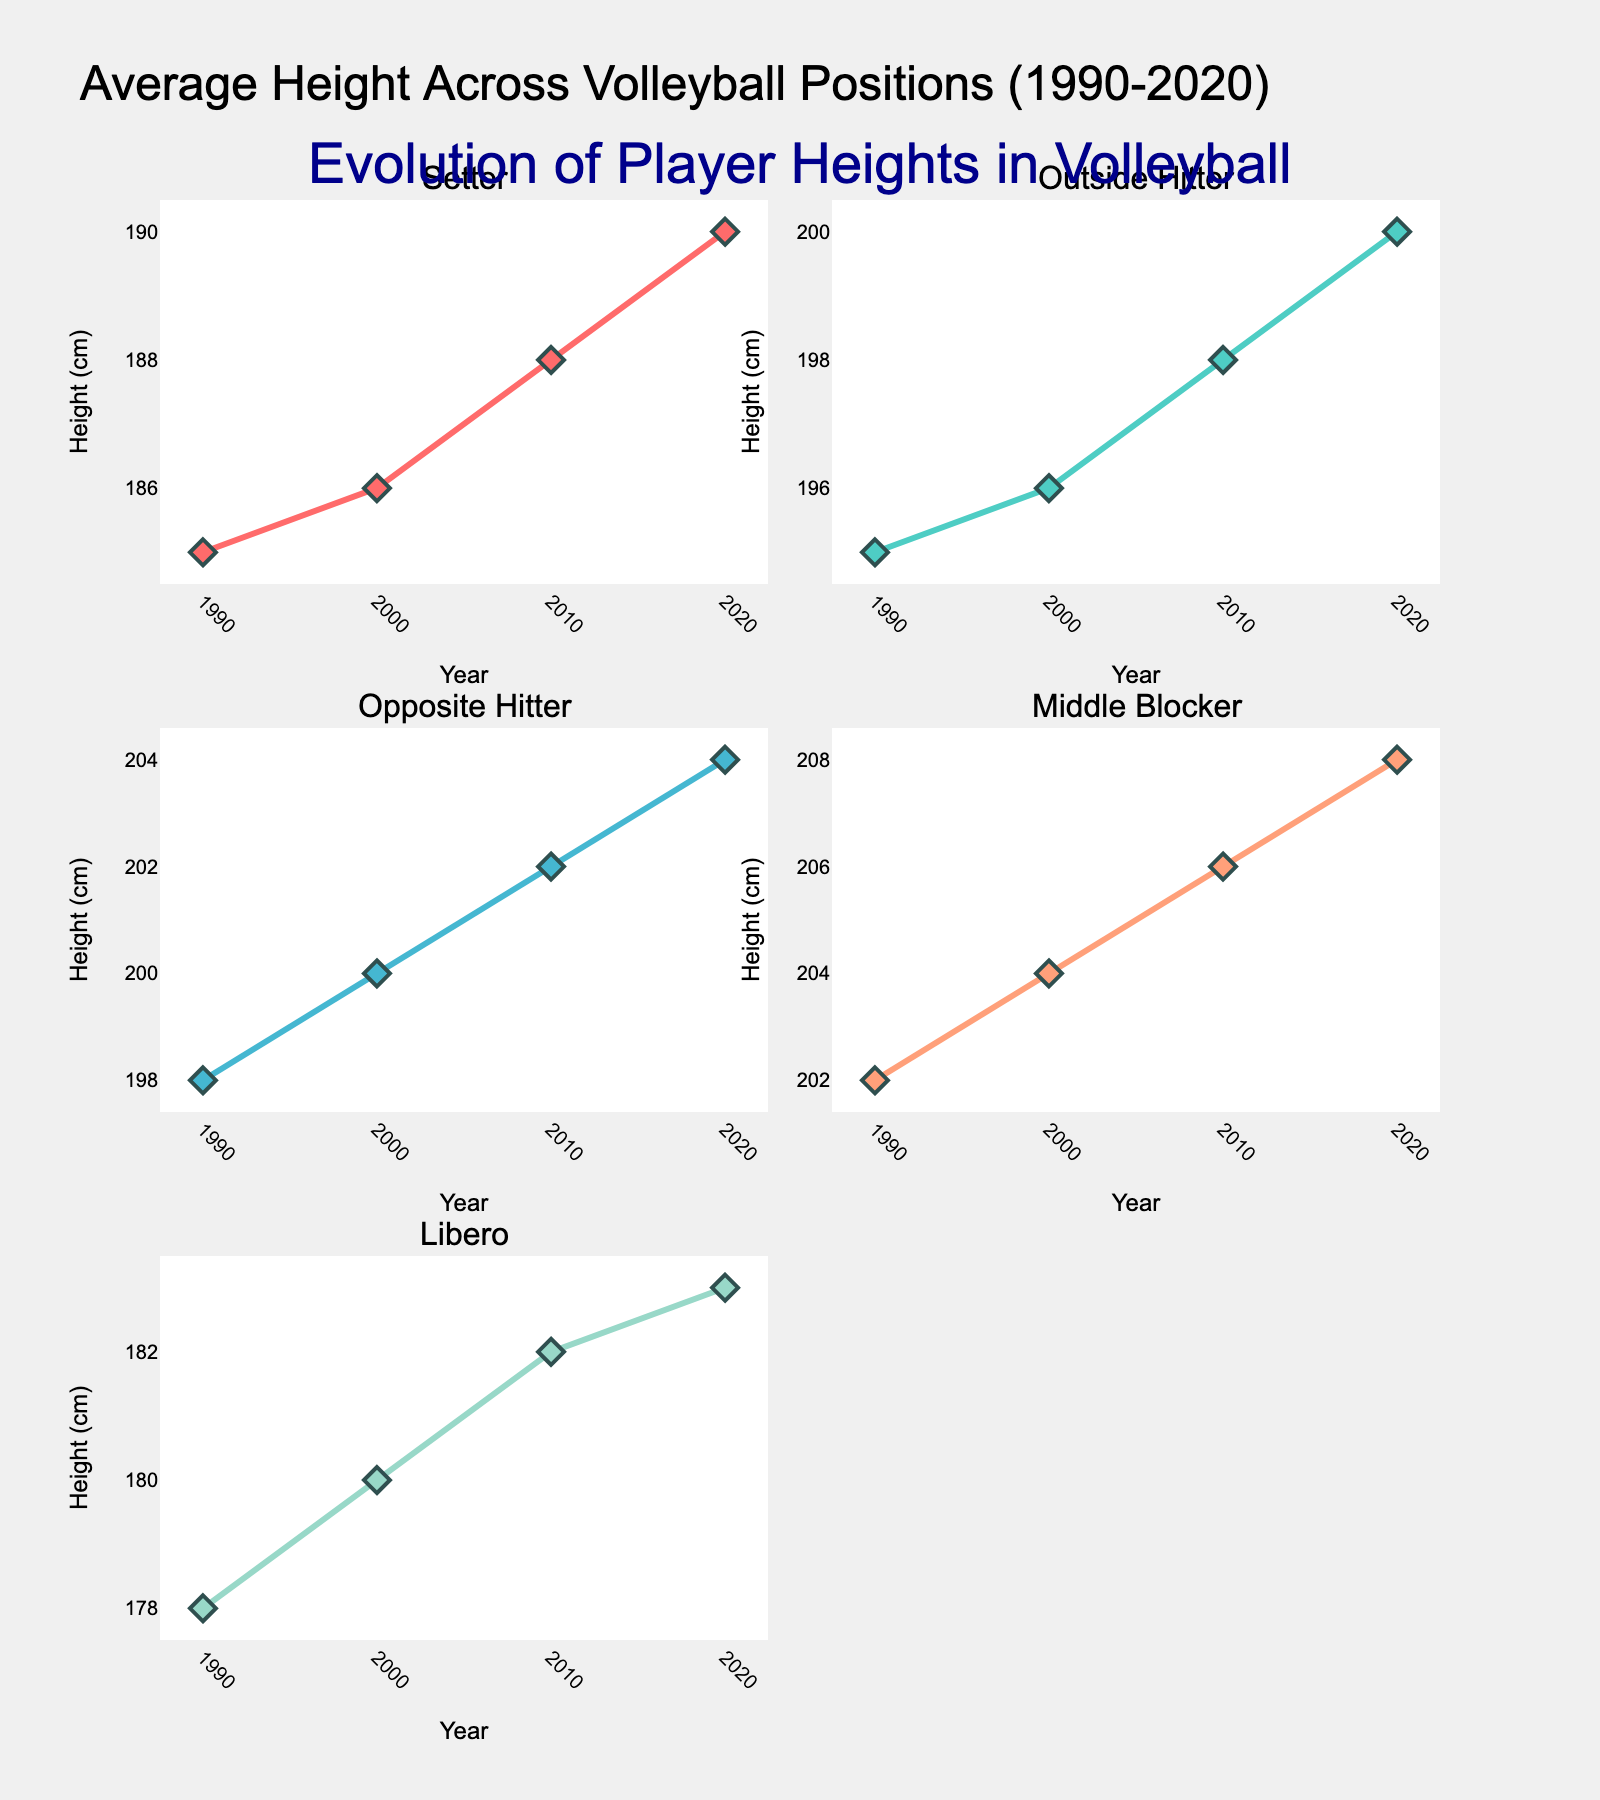What is the main title of the figure? The main title is displayed prominently at the top of the figure. By reading what is there, we can answer this question.
Answer: "Average Height Across Volleyball Positions (1990-2020)" Which volleyball position showed the most consistent increase in height over the years? Observing the slope of the lines for each position across the years, we see which line steadily increases without fluctuations. Each position line shows slight increases, but the Middle Blocker has the most linear and consistent increase.
Answer: Middle Blocker How has the average height of the Setter position changed from 1990 to 2020? By comparing the first and last data points of the Setter plot, we see the change. Starting in 1990 at 185 cm and increasing to 190 cm in 2020, the difference is observed.
Answer: Increased by 5 cm Which year had the highest average height for Outside Hitters? The subplot for Outside Hitters shows the height for each year. By finding the maximum value within the years and corresponding height, we identify the year.
Answer: 2020 What is the difference in height between Outside Hitters and Middle Blockers in 2000? Looking at the figure for both positions in the year 2000, Outside Hitters are at 196 cm, and Middle Blockers are at 204 cm. Subtracting these values gives the height difference.
Answer: 8 cm How many subplots does the figure contain? By counting the individual plots arranged for each volleyball position, we can sum up the total number. There are separate plots for Setter, Outside Hitter, Opposite Hitter, Middle Blocker, and Libero, laid out in the subplot grid.
Answer: 5 Between which years did the Libero position see the biggest change in average height? Looking at the diagram for the Libero position, the heights are listed for each decade. By calculating the differences between each decade and comparing them, we identify the largest change. From 1990 (178 cm) to 2000 (180 cm), the change is 2 cm, from 2000 to 2010 (182 cm) is 2 cm, and from 2010 to 2020 (183 cm) is 1 cm. The largest change is equal between 2000 and 2010.
Answer: 2000 to 2010 Which position had the smallest average height increase from 1990 to 2020? Checking the height changes for each position over time, the Setter’s height increase is from 185 cm to 190 cm (5 cm), Outside Hitter from 195 cm to 200 cm (5 cm), Opposite Hitter from 198 cm to 204 cm (6 cm), Middle Blocker from 202 cm to 208 cm (6 cm), Libero from 178 cm to 183 cm (5 cm). All increases are closely similar, but the Setter, Outside Hitter, and Libero tie for the smallest increase.
Answer: Setter, Outside Hitter, and Libero Which volleyball position had the largest height in 1990? By looking at the plot data points for the year 1990, we identify the tallest initial height among the positions. Middle Blockers start with the greatest height at 202 cm.
Answer: Middle Blocker What colors are used in the subplots for the Libero position? Viewing the color palette chosen for each subplot, we can see that the Libero position has a color different from others. The chosen color for Libero is seen with a light greenish-blue tone, distinguishing it from others.
Answer: Light greenish-blue 